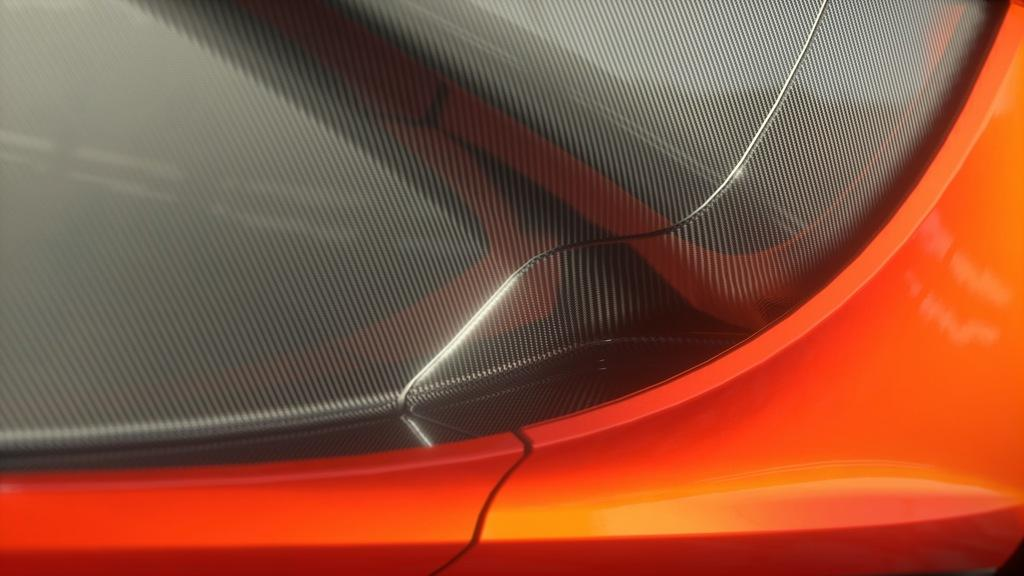What is the color of the object in the image? The object in the image is black and orange. What might the object be a part of? The object might be a part of a car. What language is the robin speaking in the image? There is no robin present in the image, and therefore no language can be attributed to it. 